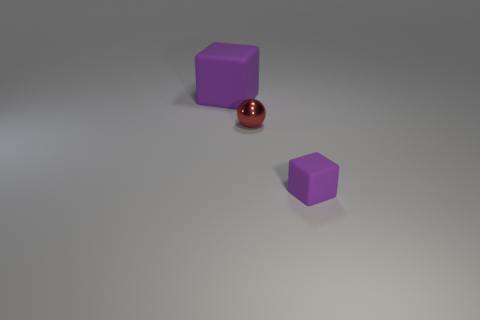There is a small metal thing; how many purple blocks are behind it?
Your response must be concise. 1. The small thing that is behind the purple matte thing that is on the right side of the large block is what shape?
Keep it short and to the point. Sphere. What is the shape of the small purple object that is the same material as the big purple thing?
Keep it short and to the point. Cube. Is the size of the rubber block behind the tiny red shiny thing the same as the purple rubber block right of the metal thing?
Keep it short and to the point. No. What is the shape of the matte thing that is to the right of the big matte cube?
Provide a succinct answer. Cube. The large rubber block is what color?
Your answer should be very brief. Purple. Do the red thing and the object that is on the left side of the red sphere have the same size?
Your answer should be very brief. No. How many metallic things are large blue things or blocks?
Offer a very short reply. 0. Is there anything else that is the same material as the red ball?
Provide a short and direct response. No. There is a tiny matte thing; is its color the same as the rubber object behind the tiny metallic sphere?
Make the answer very short. Yes. 